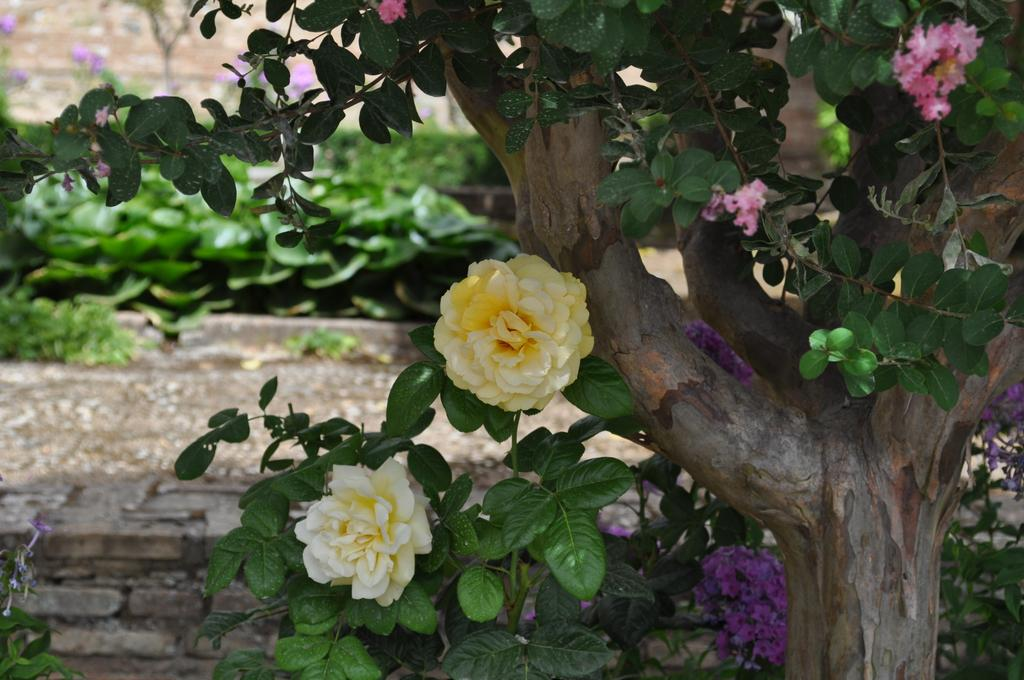What type of plant is located on the right side of the image? There is a flower plant on the right side of the image. What can be seen on the left side of the image? There are other plants on the left side of the image. What type of copper material is present in the image? There is no copper material present in the image; it features plants. Where can the magic be seen in the image? There is no magic present in the image; it features plants. 